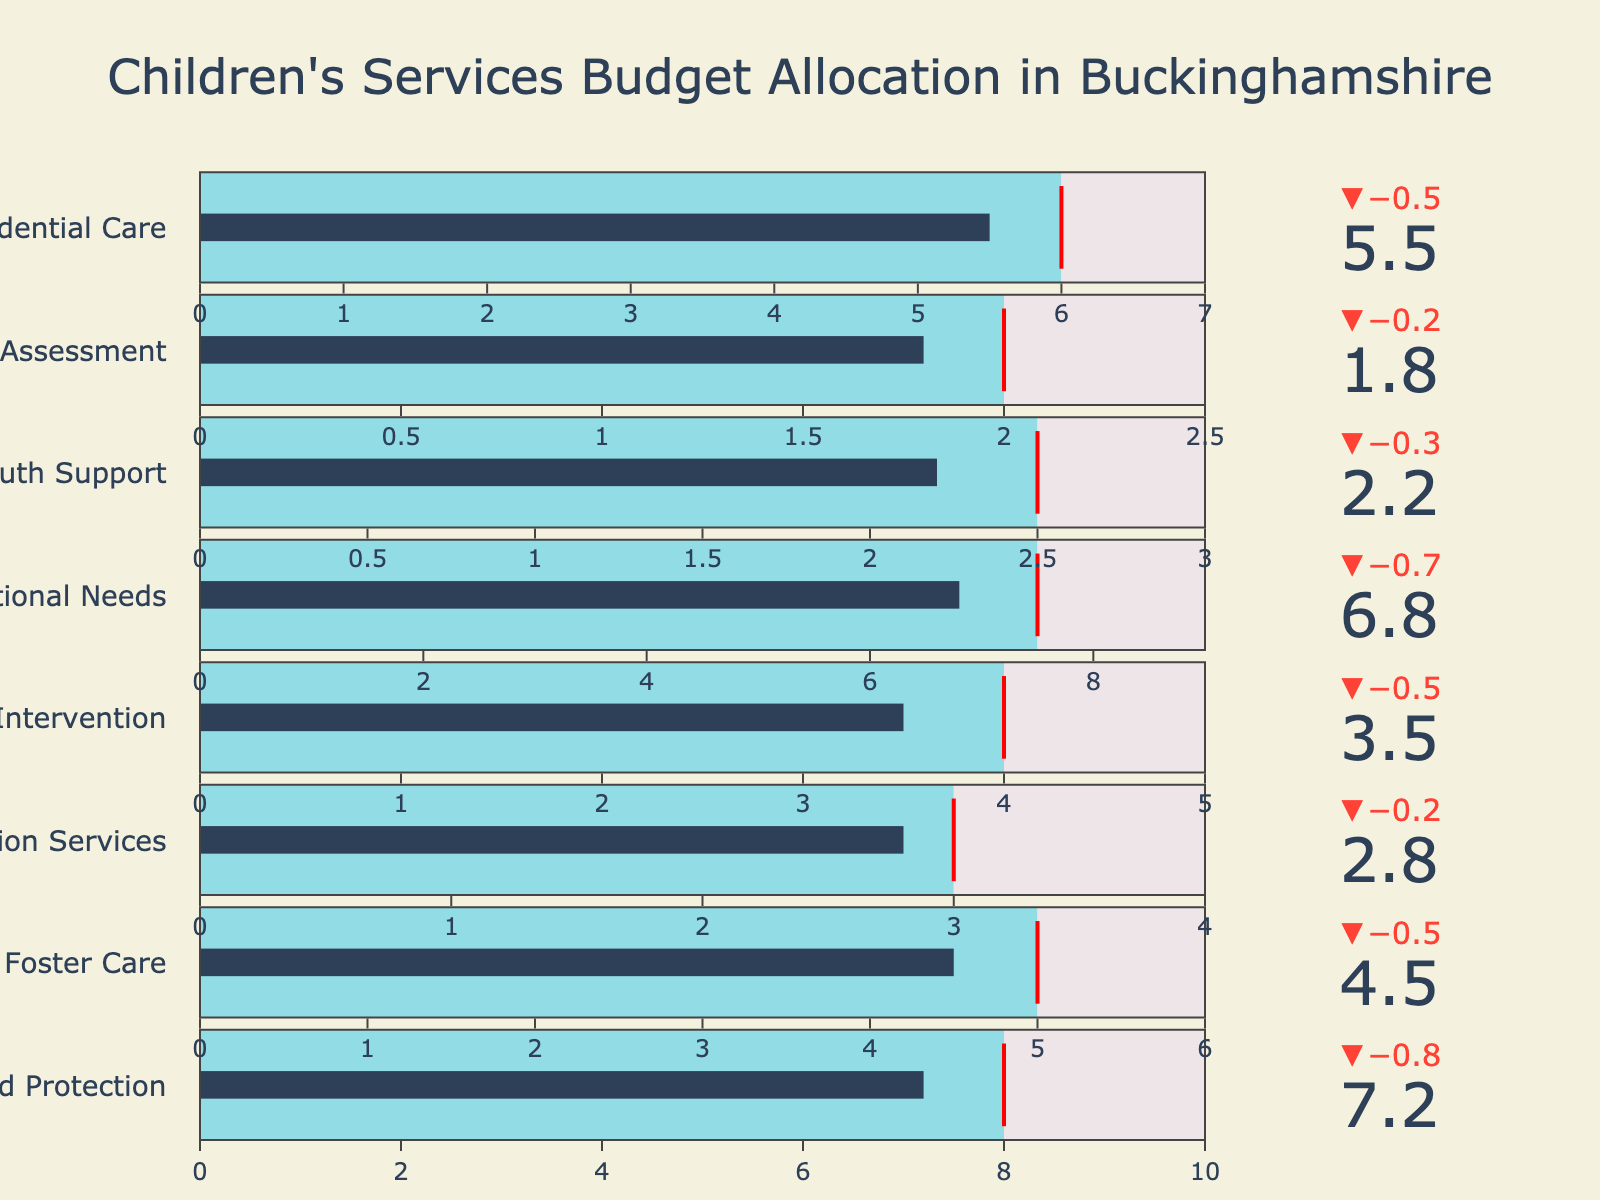What is the title of the chart? The title is located at the top of the chart and summarizes what the chart represents.
Answer: Children's Services Budget Allocation in Buckinghamshire How many categories are presented in the chart? Count the number of bullet charts listed vertically.
Answer: 8 What is the actual spending for Early Intervention? Look at the bullet chart labeled Early Intervention; the actual spending is represented by the bar's endpoint.
Answer: 3.5 Which category has the highest target value? Compare the target values (marked by a line within each bullet chart) for all categories.
Answer: Child Protection Which category's actual spending exceeds its target value the most? Identify the bullet chart where the bar (actual spending) exceeds the line (target) by the largest amount. Calculate the difference for each category where actual exceeds target.
Answer: Child Protection by 0.2 (7.2 - 8.0) What is the combined actual spending for Foster Care and Adoption Services? Sum the actual spending values for Foster Care and Adoption Services.
Answer: 4.5 + 2.8 = 7.3 How does actual spending for Residential Care compare to its target? Look at the Residential Care bullet chart and compare the actual spending bar to the target line.
Answer: 5.5 is 0.5 below the target of 6.0 Which category is closest to meeting its maximum budget without exceeding it? Compare each category's actual spending to its maximum value and find the smallest difference where the actual is less than or equal to the maximum.
Answer: Foster Care (4.5 and 6.0) 